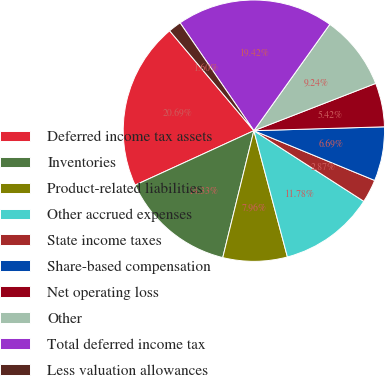Convert chart to OTSL. <chart><loc_0><loc_0><loc_500><loc_500><pie_chart><fcel>Deferred income tax assets<fcel>Inventories<fcel>Product-related liabilities<fcel>Other accrued expenses<fcel>State income taxes<fcel>Share-based compensation<fcel>Net operating loss<fcel>Other<fcel>Total deferred income tax<fcel>Less valuation allowances<nl><fcel>20.69%<fcel>14.33%<fcel>7.96%<fcel>11.78%<fcel>2.87%<fcel>6.69%<fcel>5.42%<fcel>9.24%<fcel>19.42%<fcel>1.6%<nl></chart> 